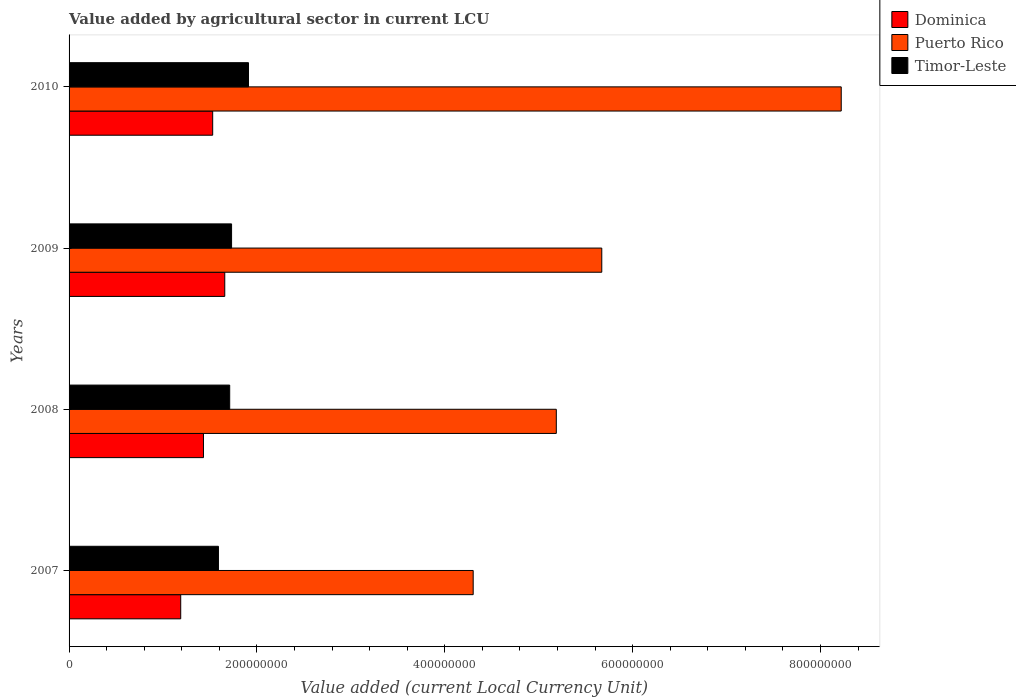How many groups of bars are there?
Give a very brief answer. 4. Are the number of bars per tick equal to the number of legend labels?
Provide a succinct answer. Yes. How many bars are there on the 4th tick from the bottom?
Provide a short and direct response. 3. What is the label of the 4th group of bars from the top?
Your answer should be compact. 2007. What is the value added by agricultural sector in Puerto Rico in 2008?
Offer a terse response. 5.19e+08. Across all years, what is the maximum value added by agricultural sector in Timor-Leste?
Keep it short and to the point. 1.91e+08. Across all years, what is the minimum value added by agricultural sector in Dominica?
Ensure brevity in your answer.  1.19e+08. In which year was the value added by agricultural sector in Puerto Rico maximum?
Offer a terse response. 2010. In which year was the value added by agricultural sector in Puerto Rico minimum?
Offer a terse response. 2007. What is the total value added by agricultural sector in Timor-Leste in the graph?
Ensure brevity in your answer.  6.94e+08. What is the difference between the value added by agricultural sector in Dominica in 2007 and that in 2009?
Ensure brevity in your answer.  -4.69e+07. What is the difference between the value added by agricultural sector in Dominica in 2010 and the value added by agricultural sector in Puerto Rico in 2009?
Make the answer very short. -4.14e+08. What is the average value added by agricultural sector in Dominica per year?
Your answer should be compact. 1.45e+08. In the year 2010, what is the difference between the value added by agricultural sector in Puerto Rico and value added by agricultural sector in Dominica?
Your response must be concise. 6.69e+08. What is the ratio of the value added by agricultural sector in Puerto Rico in 2009 to that in 2010?
Ensure brevity in your answer.  0.69. Is the value added by agricultural sector in Timor-Leste in 2007 less than that in 2008?
Your response must be concise. Yes. What is the difference between the highest and the second highest value added by agricultural sector in Dominica?
Provide a succinct answer. 1.29e+07. What is the difference between the highest and the lowest value added by agricultural sector in Timor-Leste?
Offer a terse response. 3.20e+07. In how many years, is the value added by agricultural sector in Dominica greater than the average value added by agricultural sector in Dominica taken over all years?
Give a very brief answer. 2. Is the sum of the value added by agricultural sector in Timor-Leste in 2007 and 2008 greater than the maximum value added by agricultural sector in Puerto Rico across all years?
Your response must be concise. No. What does the 2nd bar from the top in 2009 represents?
Your answer should be compact. Puerto Rico. What does the 1st bar from the bottom in 2010 represents?
Your answer should be very brief. Dominica. Are all the bars in the graph horizontal?
Offer a terse response. Yes. What is the difference between two consecutive major ticks on the X-axis?
Ensure brevity in your answer.  2.00e+08. How are the legend labels stacked?
Make the answer very short. Vertical. What is the title of the graph?
Make the answer very short. Value added by agricultural sector in current LCU. Does "Cayman Islands" appear as one of the legend labels in the graph?
Your answer should be compact. No. What is the label or title of the X-axis?
Keep it short and to the point. Value added (current Local Currency Unit). What is the Value added (current Local Currency Unit) of Dominica in 2007?
Offer a very short reply. 1.19e+08. What is the Value added (current Local Currency Unit) in Puerto Rico in 2007?
Offer a terse response. 4.30e+08. What is the Value added (current Local Currency Unit) of Timor-Leste in 2007?
Offer a terse response. 1.59e+08. What is the Value added (current Local Currency Unit) of Dominica in 2008?
Provide a succinct answer. 1.43e+08. What is the Value added (current Local Currency Unit) of Puerto Rico in 2008?
Offer a terse response. 5.19e+08. What is the Value added (current Local Currency Unit) of Timor-Leste in 2008?
Make the answer very short. 1.71e+08. What is the Value added (current Local Currency Unit) of Dominica in 2009?
Keep it short and to the point. 1.66e+08. What is the Value added (current Local Currency Unit) in Puerto Rico in 2009?
Give a very brief answer. 5.67e+08. What is the Value added (current Local Currency Unit) of Timor-Leste in 2009?
Offer a terse response. 1.73e+08. What is the Value added (current Local Currency Unit) in Dominica in 2010?
Your answer should be compact. 1.53e+08. What is the Value added (current Local Currency Unit) of Puerto Rico in 2010?
Offer a terse response. 8.22e+08. What is the Value added (current Local Currency Unit) of Timor-Leste in 2010?
Keep it short and to the point. 1.91e+08. Across all years, what is the maximum Value added (current Local Currency Unit) of Dominica?
Your answer should be very brief. 1.66e+08. Across all years, what is the maximum Value added (current Local Currency Unit) in Puerto Rico?
Your answer should be very brief. 8.22e+08. Across all years, what is the maximum Value added (current Local Currency Unit) of Timor-Leste?
Your answer should be very brief. 1.91e+08. Across all years, what is the minimum Value added (current Local Currency Unit) of Dominica?
Offer a very short reply. 1.19e+08. Across all years, what is the minimum Value added (current Local Currency Unit) in Puerto Rico?
Your response must be concise. 4.30e+08. Across all years, what is the minimum Value added (current Local Currency Unit) in Timor-Leste?
Offer a very short reply. 1.59e+08. What is the total Value added (current Local Currency Unit) of Dominica in the graph?
Ensure brevity in your answer.  5.81e+08. What is the total Value added (current Local Currency Unit) of Puerto Rico in the graph?
Your response must be concise. 2.34e+09. What is the total Value added (current Local Currency Unit) of Timor-Leste in the graph?
Your answer should be compact. 6.94e+08. What is the difference between the Value added (current Local Currency Unit) of Dominica in 2007 and that in 2008?
Ensure brevity in your answer.  -2.42e+07. What is the difference between the Value added (current Local Currency Unit) of Puerto Rico in 2007 and that in 2008?
Offer a very short reply. -8.85e+07. What is the difference between the Value added (current Local Currency Unit) of Timor-Leste in 2007 and that in 2008?
Your response must be concise. -1.20e+07. What is the difference between the Value added (current Local Currency Unit) in Dominica in 2007 and that in 2009?
Keep it short and to the point. -4.69e+07. What is the difference between the Value added (current Local Currency Unit) in Puerto Rico in 2007 and that in 2009?
Your answer should be compact. -1.37e+08. What is the difference between the Value added (current Local Currency Unit) of Timor-Leste in 2007 and that in 2009?
Offer a terse response. -1.40e+07. What is the difference between the Value added (current Local Currency Unit) of Dominica in 2007 and that in 2010?
Your answer should be compact. -3.40e+07. What is the difference between the Value added (current Local Currency Unit) of Puerto Rico in 2007 and that in 2010?
Your answer should be compact. -3.92e+08. What is the difference between the Value added (current Local Currency Unit) in Timor-Leste in 2007 and that in 2010?
Make the answer very short. -3.20e+07. What is the difference between the Value added (current Local Currency Unit) in Dominica in 2008 and that in 2009?
Provide a succinct answer. -2.27e+07. What is the difference between the Value added (current Local Currency Unit) in Puerto Rico in 2008 and that in 2009?
Offer a terse response. -4.84e+07. What is the difference between the Value added (current Local Currency Unit) in Timor-Leste in 2008 and that in 2009?
Make the answer very short. -2.00e+06. What is the difference between the Value added (current Local Currency Unit) of Dominica in 2008 and that in 2010?
Provide a short and direct response. -9.81e+06. What is the difference between the Value added (current Local Currency Unit) in Puerto Rico in 2008 and that in 2010?
Give a very brief answer. -3.03e+08. What is the difference between the Value added (current Local Currency Unit) of Timor-Leste in 2008 and that in 2010?
Your response must be concise. -2.00e+07. What is the difference between the Value added (current Local Currency Unit) of Dominica in 2009 and that in 2010?
Provide a short and direct response. 1.29e+07. What is the difference between the Value added (current Local Currency Unit) of Puerto Rico in 2009 and that in 2010?
Give a very brief answer. -2.55e+08. What is the difference between the Value added (current Local Currency Unit) in Timor-Leste in 2009 and that in 2010?
Your answer should be very brief. -1.80e+07. What is the difference between the Value added (current Local Currency Unit) in Dominica in 2007 and the Value added (current Local Currency Unit) in Puerto Rico in 2008?
Offer a very short reply. -4.00e+08. What is the difference between the Value added (current Local Currency Unit) in Dominica in 2007 and the Value added (current Local Currency Unit) in Timor-Leste in 2008?
Your response must be concise. -5.21e+07. What is the difference between the Value added (current Local Currency Unit) of Puerto Rico in 2007 and the Value added (current Local Currency Unit) of Timor-Leste in 2008?
Keep it short and to the point. 2.59e+08. What is the difference between the Value added (current Local Currency Unit) in Dominica in 2007 and the Value added (current Local Currency Unit) in Puerto Rico in 2009?
Your answer should be compact. -4.48e+08. What is the difference between the Value added (current Local Currency Unit) of Dominica in 2007 and the Value added (current Local Currency Unit) of Timor-Leste in 2009?
Your answer should be compact. -5.41e+07. What is the difference between the Value added (current Local Currency Unit) in Puerto Rico in 2007 and the Value added (current Local Currency Unit) in Timor-Leste in 2009?
Provide a short and direct response. 2.57e+08. What is the difference between the Value added (current Local Currency Unit) in Dominica in 2007 and the Value added (current Local Currency Unit) in Puerto Rico in 2010?
Offer a very short reply. -7.03e+08. What is the difference between the Value added (current Local Currency Unit) in Dominica in 2007 and the Value added (current Local Currency Unit) in Timor-Leste in 2010?
Provide a short and direct response. -7.21e+07. What is the difference between the Value added (current Local Currency Unit) in Puerto Rico in 2007 and the Value added (current Local Currency Unit) in Timor-Leste in 2010?
Make the answer very short. 2.39e+08. What is the difference between the Value added (current Local Currency Unit) of Dominica in 2008 and the Value added (current Local Currency Unit) of Puerto Rico in 2009?
Make the answer very short. -4.24e+08. What is the difference between the Value added (current Local Currency Unit) in Dominica in 2008 and the Value added (current Local Currency Unit) in Timor-Leste in 2009?
Ensure brevity in your answer.  -2.99e+07. What is the difference between the Value added (current Local Currency Unit) of Puerto Rico in 2008 and the Value added (current Local Currency Unit) of Timor-Leste in 2009?
Provide a succinct answer. 3.46e+08. What is the difference between the Value added (current Local Currency Unit) in Dominica in 2008 and the Value added (current Local Currency Unit) in Puerto Rico in 2010?
Offer a terse response. -6.79e+08. What is the difference between the Value added (current Local Currency Unit) in Dominica in 2008 and the Value added (current Local Currency Unit) in Timor-Leste in 2010?
Your answer should be compact. -4.79e+07. What is the difference between the Value added (current Local Currency Unit) in Puerto Rico in 2008 and the Value added (current Local Currency Unit) in Timor-Leste in 2010?
Keep it short and to the point. 3.28e+08. What is the difference between the Value added (current Local Currency Unit) of Dominica in 2009 and the Value added (current Local Currency Unit) of Puerto Rico in 2010?
Offer a terse response. -6.56e+08. What is the difference between the Value added (current Local Currency Unit) of Dominica in 2009 and the Value added (current Local Currency Unit) of Timor-Leste in 2010?
Your response must be concise. -2.53e+07. What is the difference between the Value added (current Local Currency Unit) of Puerto Rico in 2009 and the Value added (current Local Currency Unit) of Timor-Leste in 2010?
Provide a short and direct response. 3.76e+08. What is the average Value added (current Local Currency Unit) in Dominica per year?
Provide a succinct answer. 1.45e+08. What is the average Value added (current Local Currency Unit) in Puerto Rico per year?
Offer a very short reply. 5.84e+08. What is the average Value added (current Local Currency Unit) in Timor-Leste per year?
Your response must be concise. 1.74e+08. In the year 2007, what is the difference between the Value added (current Local Currency Unit) of Dominica and Value added (current Local Currency Unit) of Puerto Rico?
Your answer should be very brief. -3.11e+08. In the year 2007, what is the difference between the Value added (current Local Currency Unit) in Dominica and Value added (current Local Currency Unit) in Timor-Leste?
Your answer should be compact. -4.01e+07. In the year 2007, what is the difference between the Value added (current Local Currency Unit) of Puerto Rico and Value added (current Local Currency Unit) of Timor-Leste?
Give a very brief answer. 2.71e+08. In the year 2008, what is the difference between the Value added (current Local Currency Unit) in Dominica and Value added (current Local Currency Unit) in Puerto Rico?
Give a very brief answer. -3.76e+08. In the year 2008, what is the difference between the Value added (current Local Currency Unit) of Dominica and Value added (current Local Currency Unit) of Timor-Leste?
Your answer should be very brief. -2.79e+07. In the year 2008, what is the difference between the Value added (current Local Currency Unit) in Puerto Rico and Value added (current Local Currency Unit) in Timor-Leste?
Offer a terse response. 3.48e+08. In the year 2009, what is the difference between the Value added (current Local Currency Unit) in Dominica and Value added (current Local Currency Unit) in Puerto Rico?
Your answer should be compact. -4.01e+08. In the year 2009, what is the difference between the Value added (current Local Currency Unit) of Dominica and Value added (current Local Currency Unit) of Timor-Leste?
Give a very brief answer. -7.26e+06. In the year 2009, what is the difference between the Value added (current Local Currency Unit) of Puerto Rico and Value added (current Local Currency Unit) of Timor-Leste?
Give a very brief answer. 3.94e+08. In the year 2010, what is the difference between the Value added (current Local Currency Unit) in Dominica and Value added (current Local Currency Unit) in Puerto Rico?
Your answer should be very brief. -6.69e+08. In the year 2010, what is the difference between the Value added (current Local Currency Unit) in Dominica and Value added (current Local Currency Unit) in Timor-Leste?
Keep it short and to the point. -3.81e+07. In the year 2010, what is the difference between the Value added (current Local Currency Unit) of Puerto Rico and Value added (current Local Currency Unit) of Timor-Leste?
Provide a succinct answer. 6.31e+08. What is the ratio of the Value added (current Local Currency Unit) in Dominica in 2007 to that in 2008?
Keep it short and to the point. 0.83. What is the ratio of the Value added (current Local Currency Unit) in Puerto Rico in 2007 to that in 2008?
Give a very brief answer. 0.83. What is the ratio of the Value added (current Local Currency Unit) in Timor-Leste in 2007 to that in 2008?
Give a very brief answer. 0.93. What is the ratio of the Value added (current Local Currency Unit) of Dominica in 2007 to that in 2009?
Make the answer very short. 0.72. What is the ratio of the Value added (current Local Currency Unit) in Puerto Rico in 2007 to that in 2009?
Your response must be concise. 0.76. What is the ratio of the Value added (current Local Currency Unit) of Timor-Leste in 2007 to that in 2009?
Keep it short and to the point. 0.92. What is the ratio of the Value added (current Local Currency Unit) in Dominica in 2007 to that in 2010?
Keep it short and to the point. 0.78. What is the ratio of the Value added (current Local Currency Unit) of Puerto Rico in 2007 to that in 2010?
Make the answer very short. 0.52. What is the ratio of the Value added (current Local Currency Unit) of Timor-Leste in 2007 to that in 2010?
Offer a terse response. 0.83. What is the ratio of the Value added (current Local Currency Unit) in Dominica in 2008 to that in 2009?
Your answer should be compact. 0.86. What is the ratio of the Value added (current Local Currency Unit) of Puerto Rico in 2008 to that in 2009?
Provide a short and direct response. 0.91. What is the ratio of the Value added (current Local Currency Unit) in Timor-Leste in 2008 to that in 2009?
Provide a short and direct response. 0.99. What is the ratio of the Value added (current Local Currency Unit) of Dominica in 2008 to that in 2010?
Your response must be concise. 0.94. What is the ratio of the Value added (current Local Currency Unit) of Puerto Rico in 2008 to that in 2010?
Offer a terse response. 0.63. What is the ratio of the Value added (current Local Currency Unit) of Timor-Leste in 2008 to that in 2010?
Keep it short and to the point. 0.9. What is the ratio of the Value added (current Local Currency Unit) in Dominica in 2009 to that in 2010?
Ensure brevity in your answer.  1.08. What is the ratio of the Value added (current Local Currency Unit) of Puerto Rico in 2009 to that in 2010?
Provide a short and direct response. 0.69. What is the ratio of the Value added (current Local Currency Unit) in Timor-Leste in 2009 to that in 2010?
Offer a very short reply. 0.91. What is the difference between the highest and the second highest Value added (current Local Currency Unit) of Dominica?
Provide a short and direct response. 1.29e+07. What is the difference between the highest and the second highest Value added (current Local Currency Unit) of Puerto Rico?
Provide a short and direct response. 2.55e+08. What is the difference between the highest and the second highest Value added (current Local Currency Unit) in Timor-Leste?
Your answer should be compact. 1.80e+07. What is the difference between the highest and the lowest Value added (current Local Currency Unit) of Dominica?
Offer a very short reply. 4.69e+07. What is the difference between the highest and the lowest Value added (current Local Currency Unit) of Puerto Rico?
Offer a very short reply. 3.92e+08. What is the difference between the highest and the lowest Value added (current Local Currency Unit) of Timor-Leste?
Keep it short and to the point. 3.20e+07. 